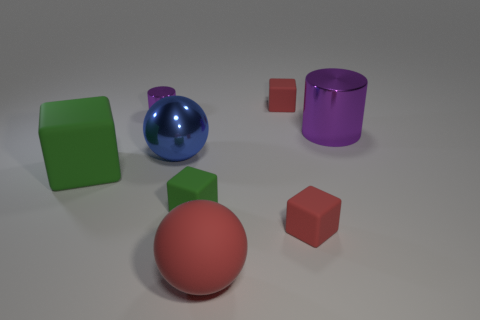Add 1 big blue shiny balls. How many objects exist? 9 Subtract all large green rubber cubes. How many cubes are left? 3 Subtract all cylinders. How many objects are left? 6 Subtract 4 cubes. How many cubes are left? 0 Add 6 big green rubber things. How many big green rubber things are left? 7 Add 3 big purple metallic cylinders. How many big purple metallic cylinders exist? 4 Subtract all red balls. How many balls are left? 1 Subtract 0 blue blocks. How many objects are left? 8 Subtract all blue balls. Subtract all cyan cylinders. How many balls are left? 1 Subtract all yellow spheres. How many yellow cubes are left? 0 